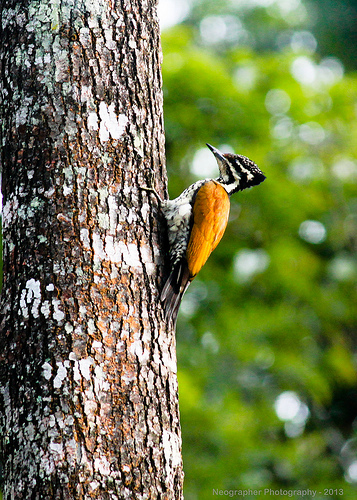What details can you provide about the tree's condition and any organisms living on it? The tree's bark displays a rough texture with patches of white mold or lichen, indicating a possibly moist environment. Additionally, the bright orange fungi-like growth suggests a symbiotic relationship, possibly involving nutrient exchange with the tree. 